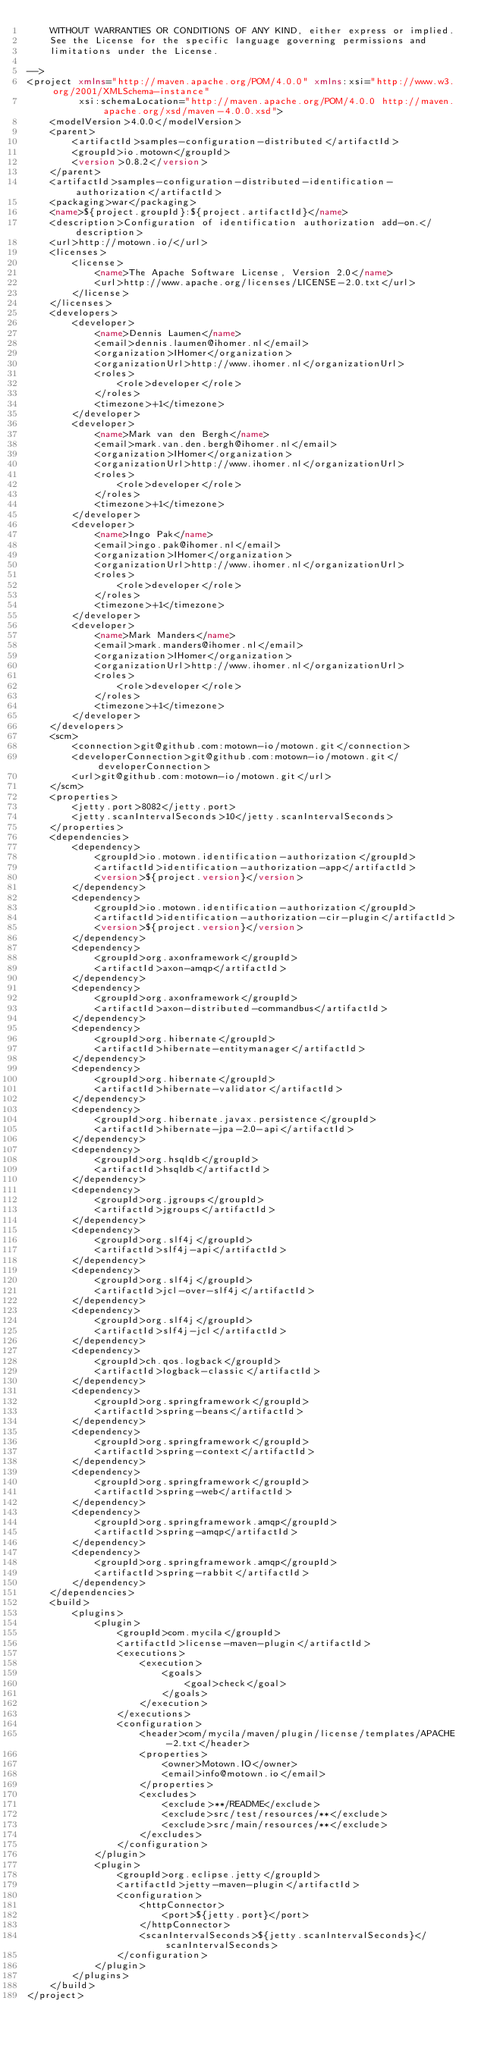<code> <loc_0><loc_0><loc_500><loc_500><_XML_>    WITHOUT WARRANTIES OR CONDITIONS OF ANY KIND, either express or implied.
    See the License for the specific language governing permissions and
    limitations under the License.

-->
<project xmlns="http://maven.apache.org/POM/4.0.0" xmlns:xsi="http://www.w3.org/2001/XMLSchema-instance"
         xsi:schemaLocation="http://maven.apache.org/POM/4.0.0 http://maven.apache.org/xsd/maven-4.0.0.xsd">
    <modelVersion>4.0.0</modelVersion>
    <parent>
        <artifactId>samples-configuration-distributed</artifactId>
        <groupId>io.motown</groupId>
        <version>0.8.2</version>
    </parent>
    <artifactId>samples-configuration-distributed-identification-authorization</artifactId>
    <packaging>war</packaging>
    <name>${project.groupId}:${project.artifactId}</name>
    <description>Configuration of identification authorization add-on.</description>
    <url>http://motown.io/</url>
    <licenses>
        <license>
            <name>The Apache Software License, Version 2.0</name>
            <url>http://www.apache.org/licenses/LICENSE-2.0.txt</url>
        </license>
    </licenses>
    <developers>
        <developer>
            <name>Dennis Laumen</name>
            <email>dennis.laumen@ihomer.nl</email>
            <organization>IHomer</organization>
            <organizationUrl>http://www.ihomer.nl</organizationUrl>
            <roles>
                <role>developer</role>
            </roles>
            <timezone>+1</timezone>
        </developer>
        <developer>
            <name>Mark van den Bergh</name>
            <email>mark.van.den.bergh@ihomer.nl</email>
            <organization>IHomer</organization>
            <organizationUrl>http://www.ihomer.nl</organizationUrl>
            <roles>
                <role>developer</role>
            </roles>
            <timezone>+1</timezone>
        </developer>
        <developer>
            <name>Ingo Pak</name>
            <email>ingo.pak@ihomer.nl</email>
            <organization>IHomer</organization>
            <organizationUrl>http://www.ihomer.nl</organizationUrl>
            <roles>
                <role>developer</role>
            </roles>
            <timezone>+1</timezone>
        </developer>
        <developer>
            <name>Mark Manders</name>
            <email>mark.manders@ihomer.nl</email>
            <organization>IHomer</organization>
            <organizationUrl>http://www.ihomer.nl</organizationUrl>
            <roles>
                <role>developer</role>
            </roles>
            <timezone>+1</timezone>
        </developer>
    </developers>
    <scm>
        <connection>git@github.com:motown-io/motown.git</connection>
        <developerConnection>git@github.com:motown-io/motown.git</developerConnection>
        <url>git@github.com:motown-io/motown.git</url>
    </scm>
    <properties>
        <jetty.port>8082</jetty.port>
        <jetty.scanIntervalSeconds>10</jetty.scanIntervalSeconds>
    </properties>
    <dependencies>
        <dependency>
            <groupId>io.motown.identification-authorization</groupId>
            <artifactId>identification-authorization-app</artifactId>
            <version>${project.version}</version>
        </dependency>
        <dependency>
            <groupId>io.motown.identification-authorization</groupId>
            <artifactId>identification-authorization-cir-plugin</artifactId>
            <version>${project.version}</version>
        </dependency>
        <dependency>
            <groupId>org.axonframework</groupId>
            <artifactId>axon-amqp</artifactId>
        </dependency>
        <dependency>
            <groupId>org.axonframework</groupId>
            <artifactId>axon-distributed-commandbus</artifactId>
        </dependency>
        <dependency>
            <groupId>org.hibernate</groupId>
            <artifactId>hibernate-entitymanager</artifactId>
        </dependency>
        <dependency>
            <groupId>org.hibernate</groupId>
            <artifactId>hibernate-validator</artifactId>
        </dependency>
        <dependency>
            <groupId>org.hibernate.javax.persistence</groupId>
            <artifactId>hibernate-jpa-2.0-api</artifactId>
        </dependency>
        <dependency>
            <groupId>org.hsqldb</groupId>
            <artifactId>hsqldb</artifactId>
        </dependency>
        <dependency>
            <groupId>org.jgroups</groupId>
            <artifactId>jgroups</artifactId>
        </dependency>
        <dependency>
            <groupId>org.slf4j</groupId>
            <artifactId>slf4j-api</artifactId>
        </dependency>
        <dependency>
            <groupId>org.slf4j</groupId>
            <artifactId>jcl-over-slf4j</artifactId>
        </dependency>
        <dependency>
            <groupId>org.slf4j</groupId>
            <artifactId>slf4j-jcl</artifactId>
        </dependency>
        <dependency>
            <groupId>ch.qos.logback</groupId>
            <artifactId>logback-classic</artifactId>
        </dependency>
        <dependency>
            <groupId>org.springframework</groupId>
            <artifactId>spring-beans</artifactId>
        </dependency>
        <dependency>
            <groupId>org.springframework</groupId>
            <artifactId>spring-context</artifactId>
        </dependency>
        <dependency>
            <groupId>org.springframework</groupId>
            <artifactId>spring-web</artifactId>
        </dependency>
        <dependency>
            <groupId>org.springframework.amqp</groupId>
            <artifactId>spring-amqp</artifactId>
        </dependency>
        <dependency>
            <groupId>org.springframework.amqp</groupId>
            <artifactId>spring-rabbit</artifactId>
        </dependency>
    </dependencies>
    <build>
        <plugins>
            <plugin>
                <groupId>com.mycila</groupId>
                <artifactId>license-maven-plugin</artifactId>
                <executions>
                    <execution>
                        <goals>
                            <goal>check</goal>
                        </goals>
                    </execution>
                </executions>
                <configuration>
                    <header>com/mycila/maven/plugin/license/templates/APACHE-2.txt</header>
                    <properties>
                        <owner>Motown.IO</owner>
                        <email>info@motown.io</email>
                    </properties>
                    <excludes>
                        <exclude>**/README</exclude>
                        <exclude>src/test/resources/**</exclude>
                        <exclude>src/main/resources/**</exclude>
                    </excludes>
                </configuration>
            </plugin>
            <plugin>
                <groupId>org.eclipse.jetty</groupId>
                <artifactId>jetty-maven-plugin</artifactId>
                <configuration>
                    <httpConnector>
                        <port>${jetty.port}</port>
                    </httpConnector>
                    <scanIntervalSeconds>${jetty.scanIntervalSeconds}</scanIntervalSeconds>
                </configuration>
            </plugin>
        </plugins>
    </build>
</project>
</code> 